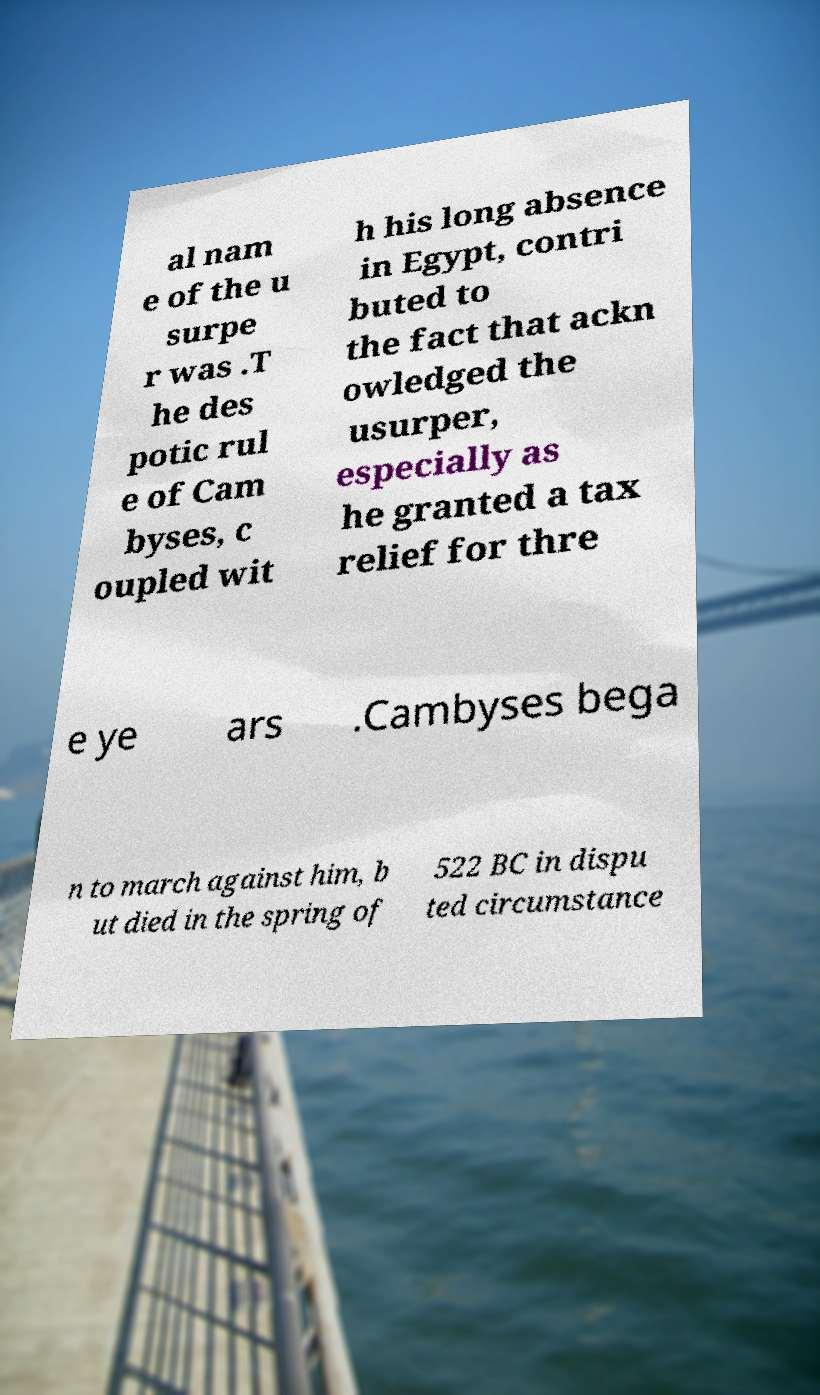There's text embedded in this image that I need extracted. Can you transcribe it verbatim? al nam e of the u surpe r was .T he des potic rul e of Cam byses, c oupled wit h his long absence in Egypt, contri buted to the fact that ackn owledged the usurper, especially as he granted a tax relief for thre e ye ars .Cambyses bega n to march against him, b ut died in the spring of 522 BC in dispu ted circumstance 